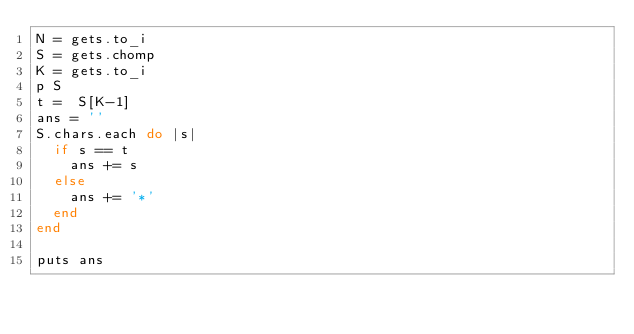Convert code to text. <code><loc_0><loc_0><loc_500><loc_500><_Ruby_>N = gets.to_i
S = gets.chomp
K = gets.to_i
p S
t =  S[K-1]
ans = ''
S.chars.each do |s|
  if s == t
    ans += s
  else
    ans += '*'
  end
end

puts ans
</code> 